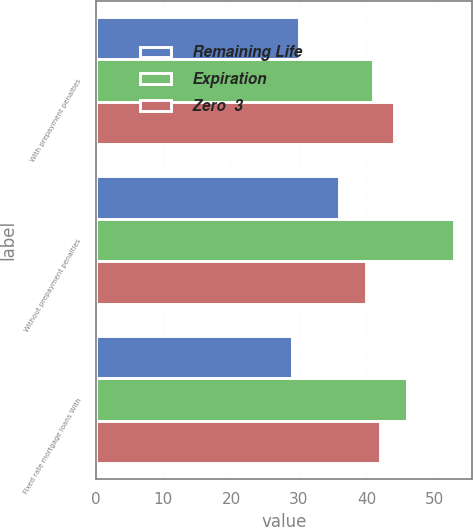<chart> <loc_0><loc_0><loc_500><loc_500><stacked_bar_chart><ecel><fcel>With prepayment penalties<fcel>Without prepayment penalties<fcel>Fixed rate mortgage loans With<nl><fcel>Remaining Life<fcel>30<fcel>36<fcel>29<nl><fcel>Expiration<fcel>41<fcel>53<fcel>46<nl><fcel>Zero  3<fcel>44<fcel>40<fcel>42<nl></chart> 